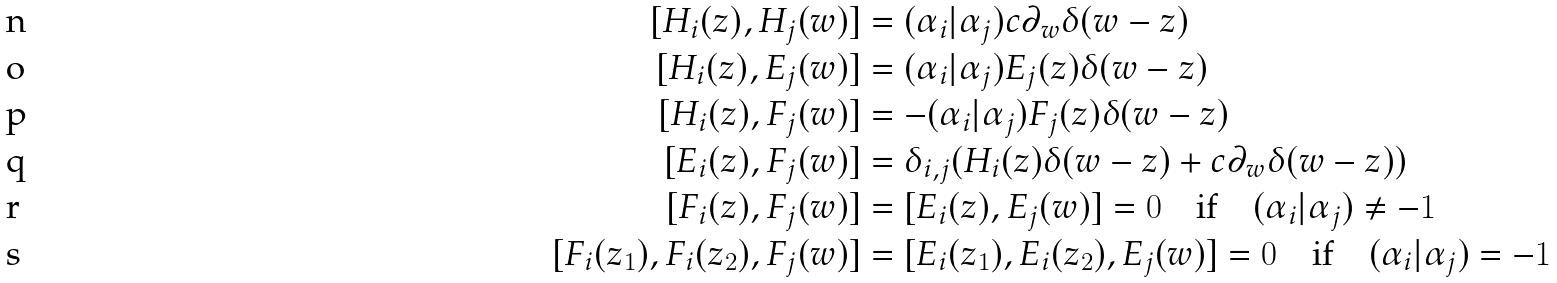Convert formula to latex. <formula><loc_0><loc_0><loc_500><loc_500>[ H _ { i } ( z ) , H _ { j } ( w ) ] & = ( \alpha _ { i } | \alpha _ { j } ) c \partial _ { w } \delta ( w - z ) \\ [ H _ { i } ( z ) , E _ { j } ( w ) ] & = ( \alpha _ { i } | \alpha _ { j } ) E _ { j } ( z ) \delta ( w - z ) \\ [ H _ { i } ( z ) , F _ { j } ( w ) ] & = - ( \alpha _ { i } | \alpha _ { j } ) F _ { j } ( z ) \delta ( w - z ) \\ [ E _ { i } ( z ) , F _ { j } ( w ) ] & = \delta _ { i , j } ( H _ { i } ( z ) \delta ( w - z ) + c \partial _ { w } \delta ( w - z ) ) \\ [ F _ { i } ( z ) , F _ { j } ( w ) ] & = [ E _ { i } ( z ) , E _ { j } ( w ) ] = 0 \quad \text {if} \quad ( \alpha _ { i } | \alpha _ { j } ) \neq - 1 \\ [ F _ { i } ( z _ { 1 } ) , F _ { i } ( z _ { 2 } ) , F _ { j } ( w ) ] & = [ E _ { i } ( z _ { 1 } ) , E _ { i } ( z _ { 2 } ) , E _ { j } ( w ) ] = 0 \quad \text {if} \quad ( \alpha _ { i } | \alpha _ { j } ) = - 1</formula> 